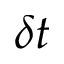Convert formula to latex. <formula><loc_0><loc_0><loc_500><loc_500>\delta t</formula> 